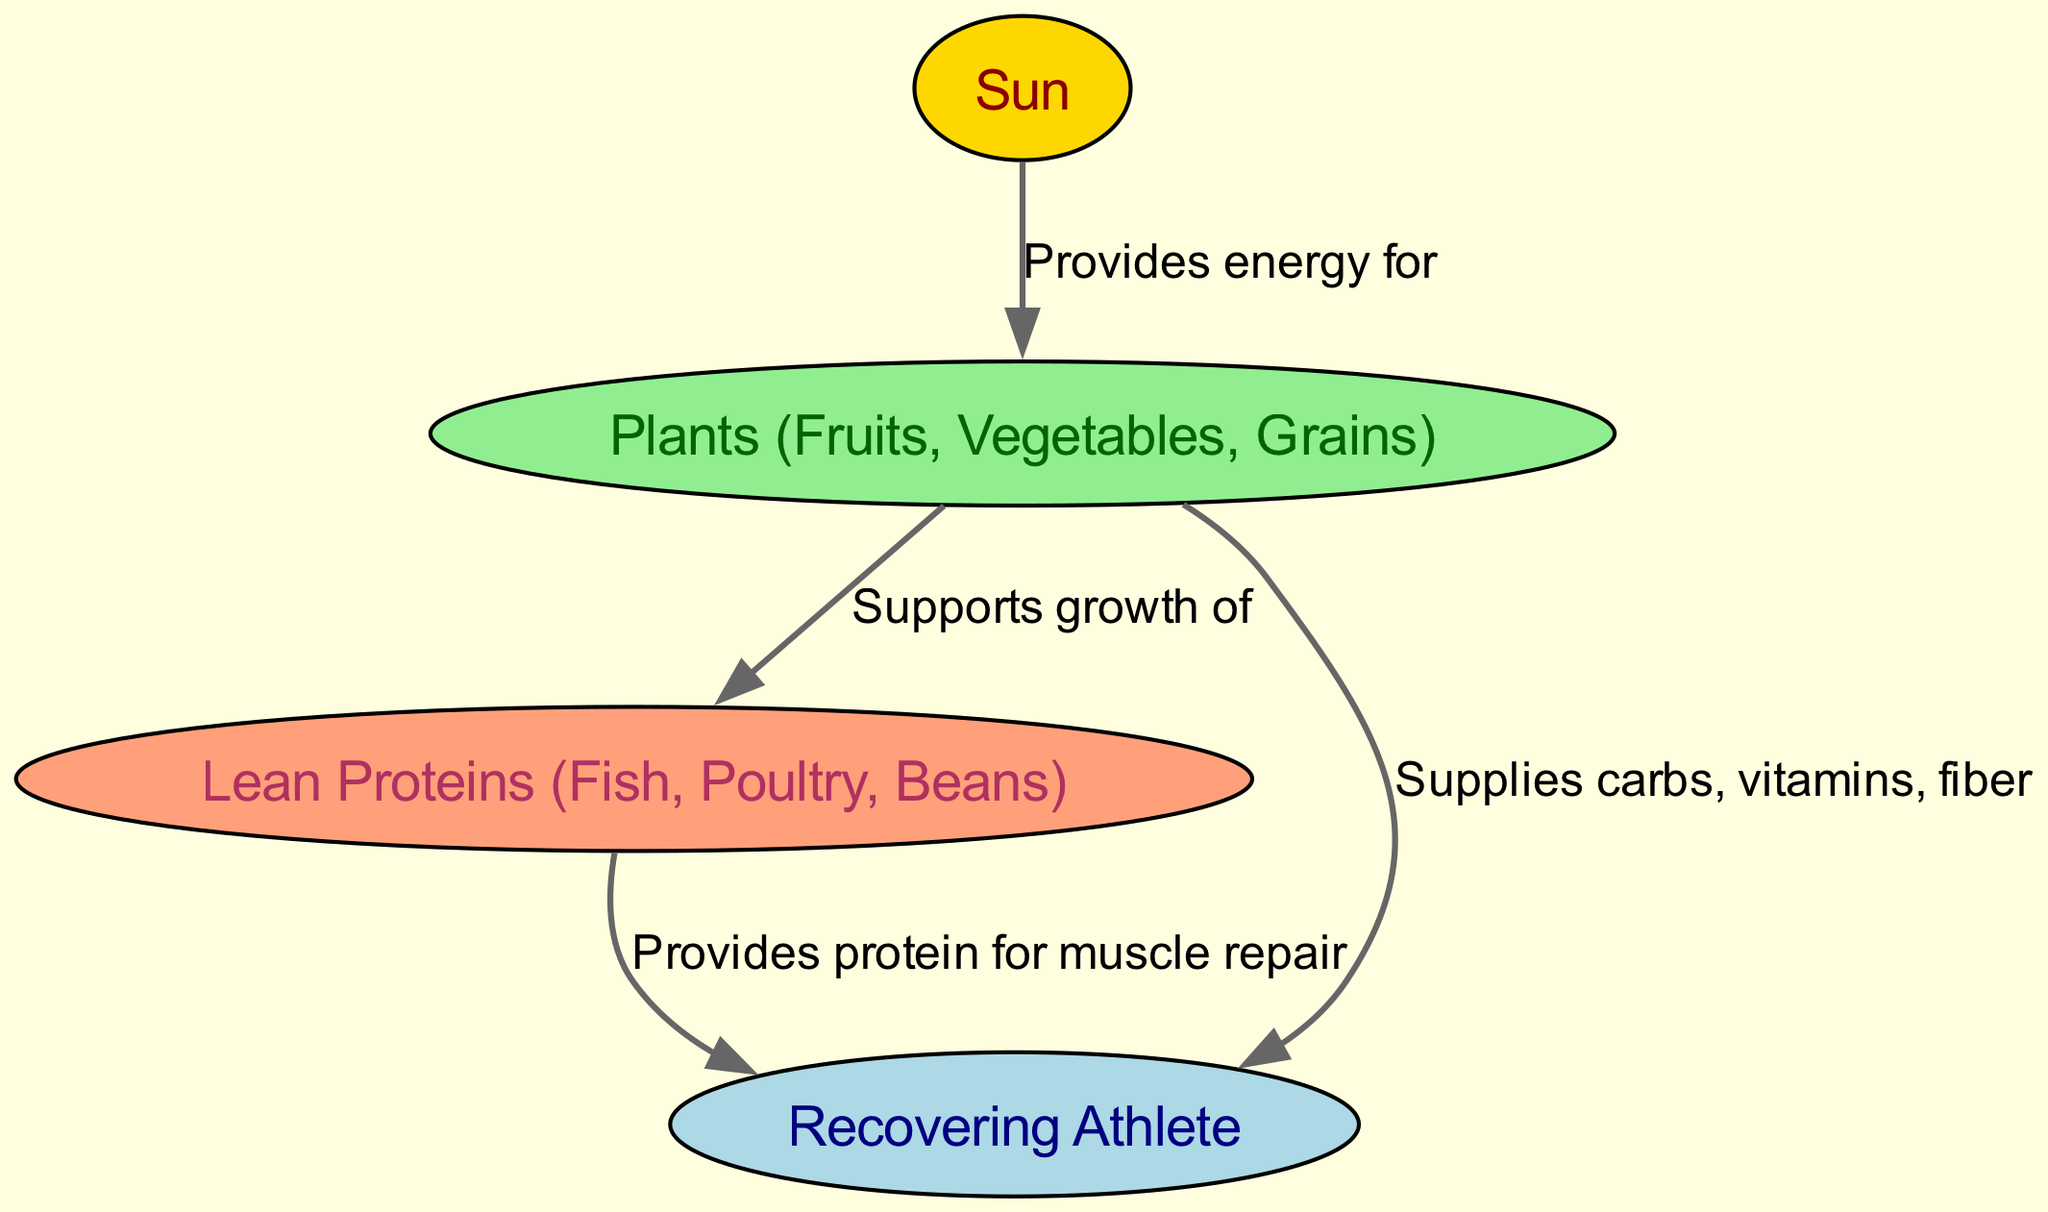What is the first node in the diagram? The diagram starts with the Sun as the first node, which is indicated at the top of the flow.
Answer: Sun How many nodes are present in the diagram? Counting the distinct nodes in the diagram, we identify four: Sun, Plants, Lean Proteins, and Recovering Athlete.
Answer: 4 What does the Sun provide energy for? The diagram clearly shows an arrow from the Sun to the Plants, indicating that it provides energy for their growth.
Answer: Plants (Fruits, Vegetables, Grains) What do Plants supply to the Recovering Athlete? The diagram illustrates that the Plants supply key nutrients such as carbohydrates, vitamins, and fiber to the athlete, as denoted by the directed edge.
Answer: Carbs, vitamins, fiber What relationship exists between Plants and Lean Proteins? There is a directed relationship shown where Plants support the growth of Lean Proteins, indicating their interdependence in the food chain.
Answer: Supports growth of How does Lean Proteins contribute to the Recovering Athlete? The diagram connects Lean Proteins to the Recovering Athlete, indicating that they provide essential protein necessary for muscle repair, which is crucial during recovery.
Answer: Provides protein for muscle repair What type of foods are categorized under Lean Proteins? The diagram includes specific examples such as Fish, Poultry, and Beans under the category of Lean Proteins, indicating the sources that help in muscle repair.
Answer: Fish, Poultry, Beans If the Recovering Athlete is not receiving enough energy from Plants, what might be impacted? The diagram suggests that insufficient energy from Plants would limit the availability of carbohydrates, vitamins, and fiber for the Recovering Athlete, which are vital for recovery.
Answer: Recovery What is the energy flow direction in this food chain? The directed edges denote the flow of energy from the Sun to the Plants, then to Lean Proteins, and finally to the Recovering Athlete, illustrating the progression of energy through the chain.
Answer: Sun → Plants → Lean Proteins → Recovering Athlete 